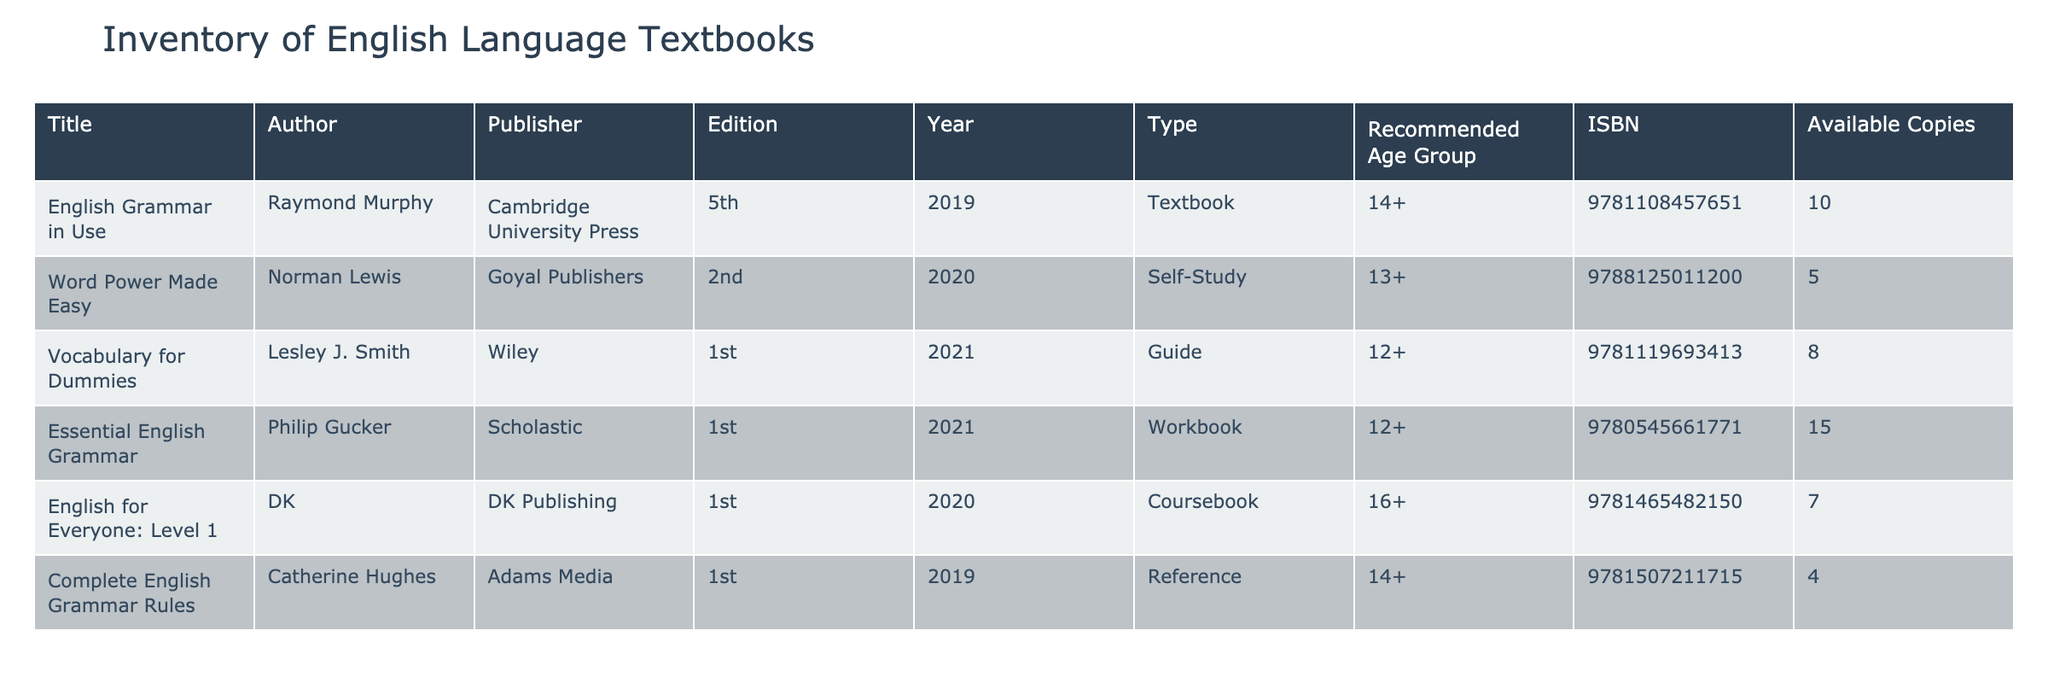What is the title of the textbook authored by Raymond Murphy? The table lists "English Grammar in Use" as the title associated with the author Raymond Murphy.
Answer: English Grammar in Use How many copies of "Essential English Grammar" are available? The table indicates that there are 15 available copies of "Essential English Grammar".
Answer: 15 Which textbook has the highest number of available copies? By examining the 'Available Copies' column, "Essential English Grammar" has 15 copies, which is higher than any other entry.
Answer: Essential English Grammar What is the combined number of available copies for textbooks suitable for age group 14+? For age group 14+, the textbooks listed are "English Grammar in Use" (10), "Complete English Grammar Rules" (4), summing them gives 10 + 4 = 14 available copies.
Answer: 14 Are there more self-study materials than workbooks in the inventory? The only self-study material is "Word Power Made Easy" (5 copies) and the only workbook is "Essential English Grammar" (15 copies), indicating that workbooks outnumber self-study materials.
Answer: No Is "Vocabulary for Dummies" suitable for students under the age of 12? The recommended age group for "Vocabulary for Dummies" is 12+, which means it is not suitable for students under the age of 12.
Answer: No What is the ISBN of the textbook that has 7 available copies? The table shows "English for Everyone: Level 1" has 7 available copies, and its ISBN is 9781465482150.
Answer: 9781465482150 If we consider only the reference books in the inventory, how many copies are available? The only reference book listed is "Complete English Grammar Rules," which has 4 available copies. Therefore, the total for reference books is 4 copies.
Answer: 4 Which author published a textbook in the year 2020? The authors of textbooks published in 2020 are Norman Lewis ("Word Power Made Easy") and DK ("English for Everyone: Level 1").
Answer: Norman Lewis, DK 